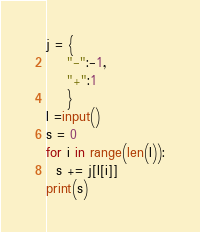<code> <loc_0><loc_0><loc_500><loc_500><_Python_>j = {
    "-":-1,
    "+":1
    }
l =input()
s = 0
for i in range(len(l)):
  s += j[l[i]]
print(s)
</code> 